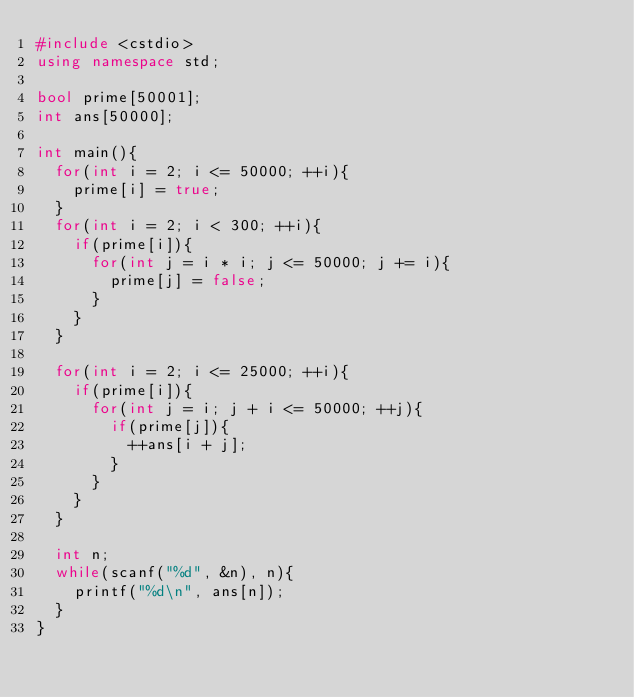Convert code to text. <code><loc_0><loc_0><loc_500><loc_500><_C++_>#include <cstdio>
using namespace std;

bool prime[50001];
int ans[50000];

int main(){
	for(int i = 2; i <= 50000; ++i){
		prime[i] = true;
	}
	for(int i = 2; i < 300; ++i){
		if(prime[i]){
			for(int j = i * i; j <= 50000; j += i){
				prime[j] = false;
			}
		}
	}
	
	for(int i = 2; i <= 25000; ++i){
		if(prime[i]){
			for(int j = i; j + i <= 50000; ++j){
				if(prime[j]){
					++ans[i + j];
				}
			}
		}
	}

	int n;
	while(scanf("%d", &n), n){
		printf("%d\n", ans[n]);
	}
}</code> 